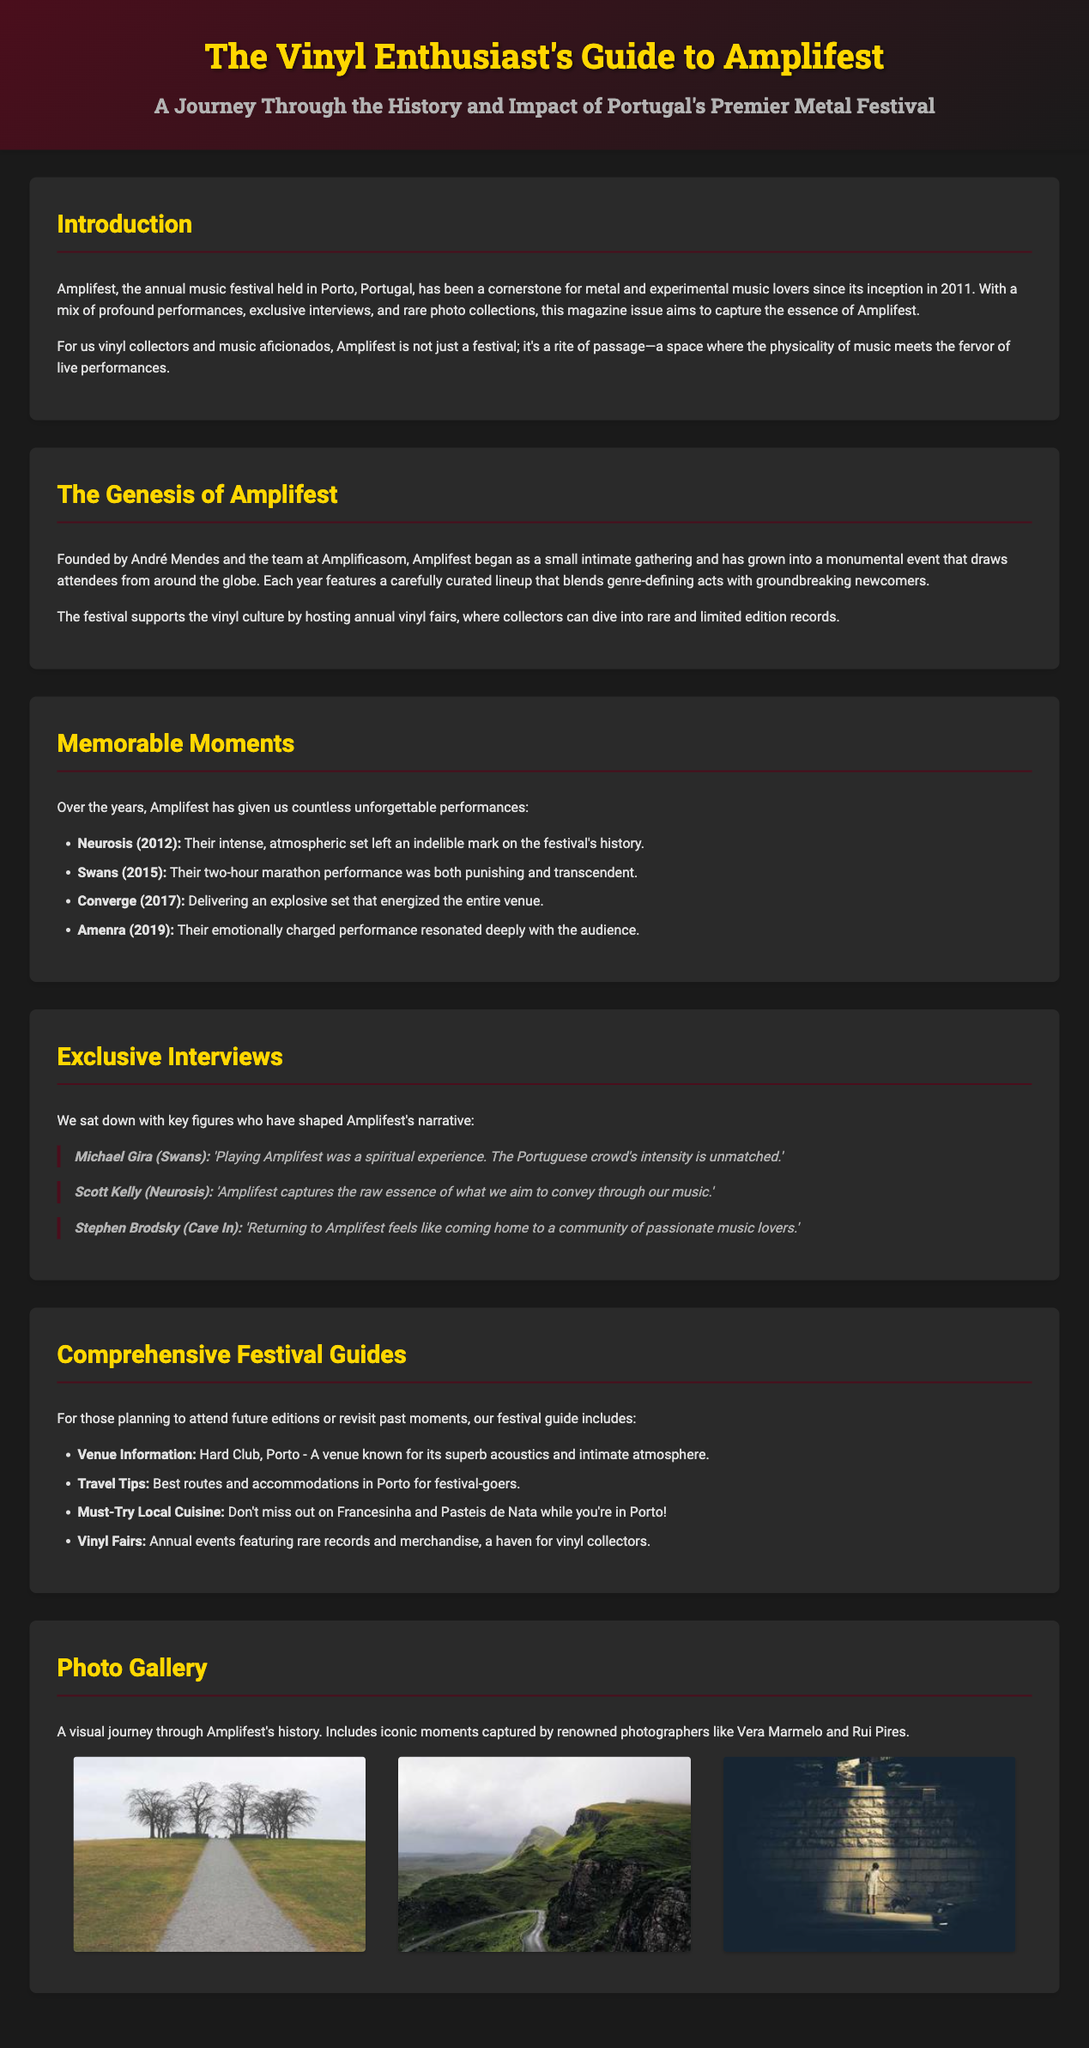What year did Amplifest start? Amplifest began in 2011, as mentioned in the introduction section of the document.
Answer: 2011 Who founded Amplifest? The document states that Amplifest was founded by André Mendes and the team at Amplificasom.
Answer: André Mendes What is the venue for Amplifest? The document provides information that Amplifest takes place at Hard Club in Porto.
Answer: Hard Club Which band performed in 2012? The document mentions Neurosis as a memorable performance in 2012.
Answer: Neurosis What local cuisine is recommended in the festival guide? The guide suggests trying Francesinha and Pasteis de Nata while in Porto.
Answer: Francesinha and Pasteis de Nata Which artist described Amplifest as a "spiritual experience"? The quote from Michael Gira indicates that he described playing at Amplifest as a spiritual experience.
Answer: Michael Gira How many memorable performances are listed? The memorable moments section includes four performances from different years.
Answer: Four What is included in the photo gallery? The photo gallery includes iconic moments captured by renowned photographers.
Answer: Iconic moments What type of magazine is this issue? The document refers to the publication as a collectible magazine issue devoted to Amplifest.
Answer: Collectible magazine 